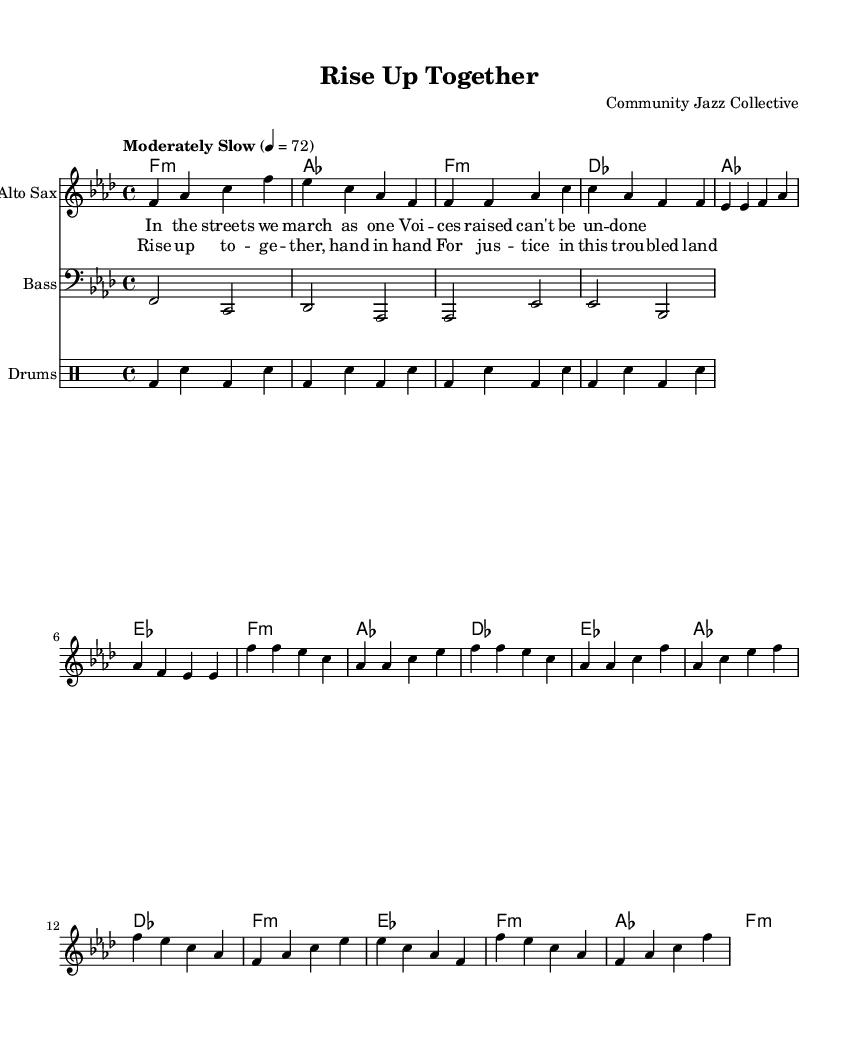What is the key signature of this music? The key signature is indicated at the beginning of the score. Here, it shows one flat, which signifies F minor.
Answer: F minor What is the time signature of the piece? The time signature is displayed at the beginning of the music, and it shows 4/4, meaning there are four beats in each measure.
Answer: 4/4 What is the tempo marking for the piece? The tempo marking is provided in the score as "Moderately Slow" with a metronome marking of 72 beats per minute. This indicates the intended speed for the performance.
Answer: Moderately Slow How many verses does the song have? By examining the structure of the song, particularly the provided lyrics, there is only one verse written, followed by a repeated chorus.
Answer: One What instruments are used in the ensemble? The score lists four types of instruments: Alto Sax, Bass, Drums, and ChordNames (harmonies). These instruments contribute to the overall jazz ensemble sound and texture.
Answer: Alto Sax, Bass, Drums What is the primary theme conveyed in the lyrics? The lyrics emphasize unity and justice, reflecting a social justice message that is commonly found in protest songs. The words focus on marching together for a cause and highlight the need for justice.
Answer: Unity and justice 